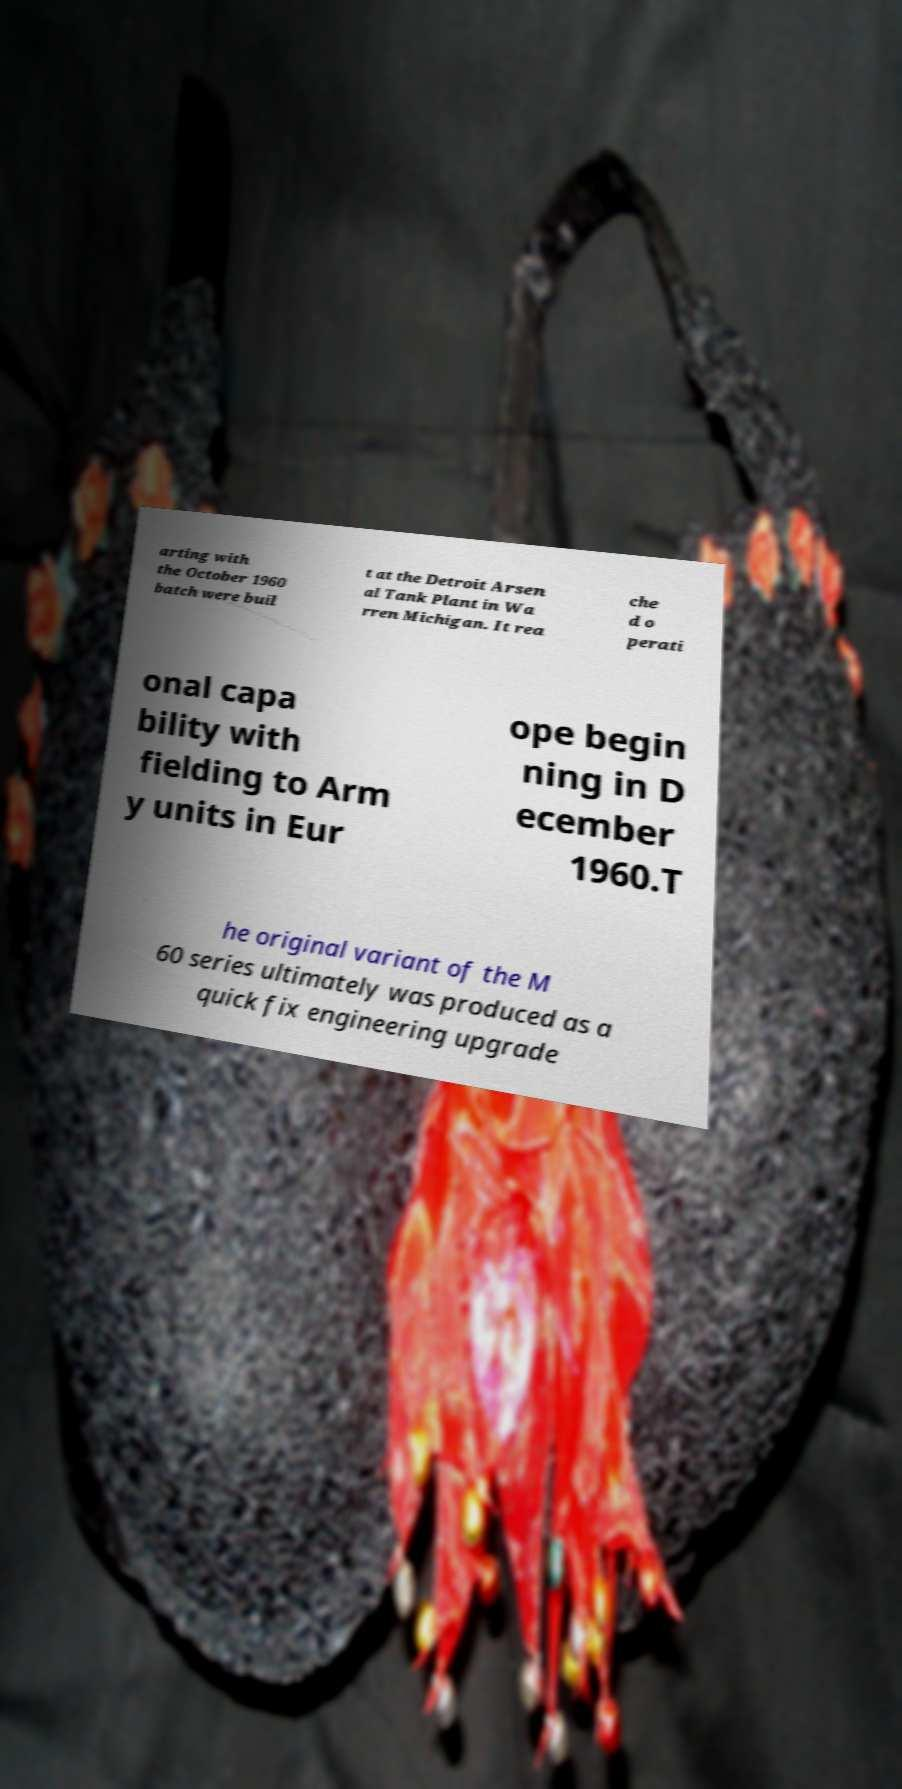For documentation purposes, I need the text within this image transcribed. Could you provide that? arting with the October 1960 batch were buil t at the Detroit Arsen al Tank Plant in Wa rren Michigan. It rea che d o perati onal capa bility with fielding to Arm y units in Eur ope begin ning in D ecember 1960.T he original variant of the M 60 series ultimately was produced as a quick fix engineering upgrade 